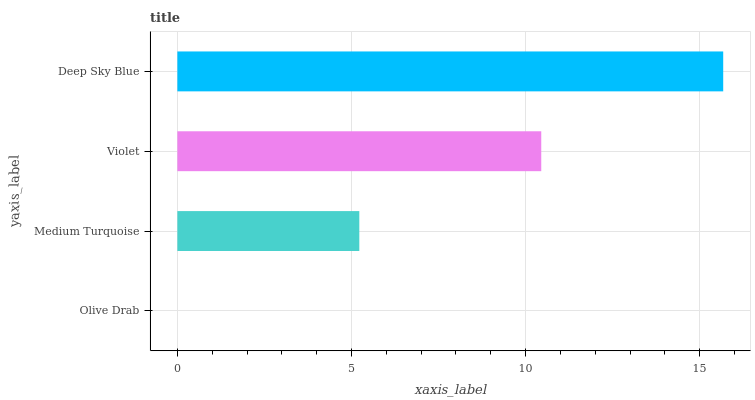Is Olive Drab the minimum?
Answer yes or no. Yes. Is Deep Sky Blue the maximum?
Answer yes or no. Yes. Is Medium Turquoise the minimum?
Answer yes or no. No. Is Medium Turquoise the maximum?
Answer yes or no. No. Is Medium Turquoise greater than Olive Drab?
Answer yes or no. Yes. Is Olive Drab less than Medium Turquoise?
Answer yes or no. Yes. Is Olive Drab greater than Medium Turquoise?
Answer yes or no. No. Is Medium Turquoise less than Olive Drab?
Answer yes or no. No. Is Violet the high median?
Answer yes or no. Yes. Is Medium Turquoise the low median?
Answer yes or no. Yes. Is Olive Drab the high median?
Answer yes or no. No. Is Violet the low median?
Answer yes or no. No. 